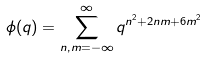Convert formula to latex. <formula><loc_0><loc_0><loc_500><loc_500>\phi ( q ) = \sum ^ { \infty } _ { n , m = - \infty } q ^ { n ^ { 2 } + 2 n m + 6 m ^ { 2 } }</formula> 